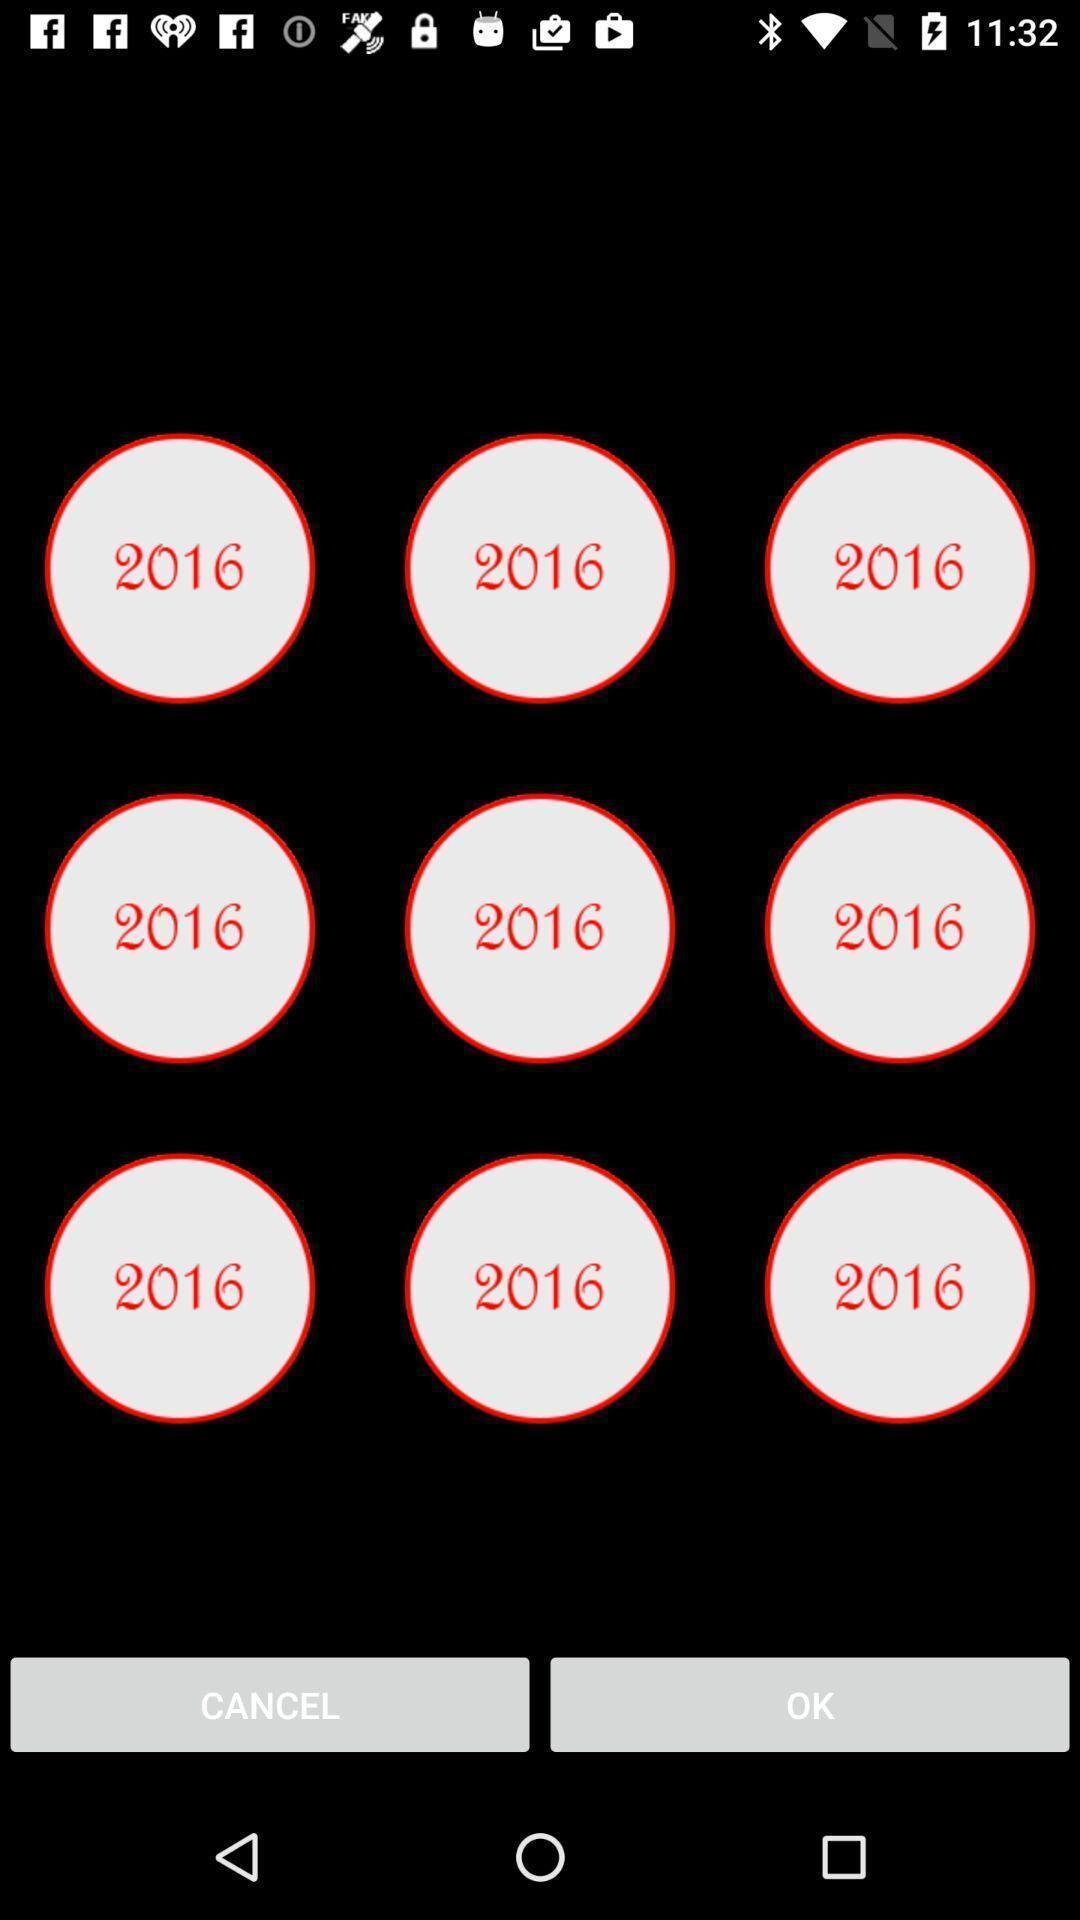Tell me about the visual elements in this screen capture. Selection for tiles. 